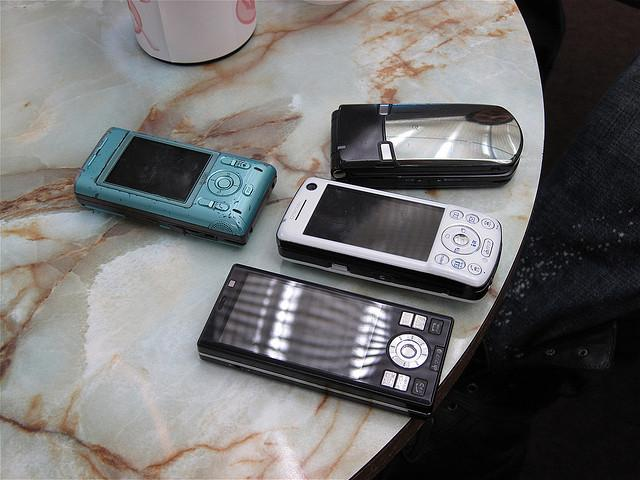What is decade are the phones most likely from?

Choices:
A) 2010's
B) 2020's
C) 1990's
D) 1970's 1990's 